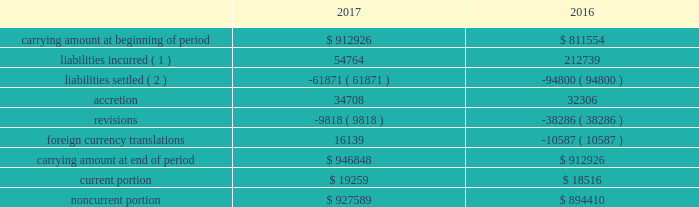14 .
Accounting for certain long-lived assets eog reviews its proved oil and gas properties for impairment purposes by comparing the expected undiscounted future cash flows at a depreciation , depletion and amortization group level to the unamortized capitalized cost of the asset .
The carrying rr values for assets determined to be impaired were adjusted to estimated fair value using the income approach described in the fair value measurement topic of the asc .
In certain instances , eog utilizes accepted offers from third-party purchasers as the basis for determining fair value .
During 2017 , proved oil and gas properties with a carrying amount of $ 370 million were written down to their fair value of $ 146 million , resulting in pretax impairment charges of $ 224 million .
During 2016 , proved oil and gas properties with a carrying rr amount of $ 643 million were written down to their fair value of $ 527 million , resulting in pretax impairment charges of $ 116 million .
Impairments in 2017 , 2016 and 2015 included domestic legacy natural gas assets .
Amortization and impairments of unproved oil and gas property costs , including amortization of capitalized interest , were $ 211 million , $ 291 million and $ 288 million during 2017 , 2016 and 2015 , respectively .
15 .
Asset retirement obligations the table presents the reconciliation of the beginning and ending aggregate carrying amounts of short-term and long-term legal obligations associated with the retirement of property , plant and equipment for the years ended december 31 , 2017 and 2016 ( in thousands ) : .
( 1 ) includes $ 164 million in 2016 related to yates transaction ( see note 17 ) .
( 2 ) includes settlements related to asset sales .
The current and noncurrent portions of eog's asset retirement obligations are included in current liabilities - other and other liabilities , respectively , on the consolidated balance sheets. .
Considering the years 2016 and 2017 , what is the increase observed in accretion? 
Rationale: it is the 2017's accretion divided by the 2016's , then subtracted 1 and turned into a percentage .
Computations: ((34708 / 32306) - 1)
Answer: 0.07435. 